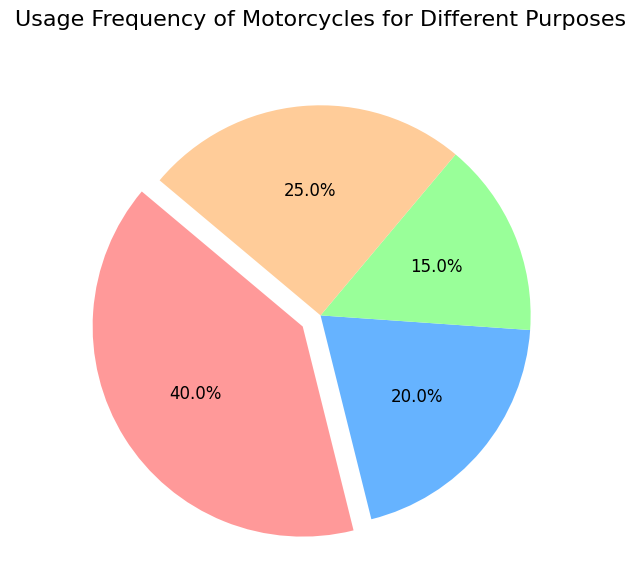What percentage of usage is for touring? To find the percentage for touring, look for the wedge labeled "Touring" and observe the percentage displayed.
Answer: 20% What is the least common purpose for motorcycle usage? By examining the pie chart, identify the smallest wedge, which is Racing.
Answer: Racing Which two purposes together sum up to 55% of motorcycle usage? Summing the percentages for Racing (15%) and Leisure (25%) gives 40%. Summing Touring (20%) and Racing (15%) gives 35%. Summing Commuting (40%) and Leisure (25%) gives 65%. Finally, if you add Commuting (40%) and Touring (20%), it sums to 60%. The closest pair is Leisure (25%) and Racing (15%) for a total of 40%. Further refinement shows Leisure (25%) and Racing (15%) totaling 40%. Continuously organizing and comparing pairs while matching the sum exactly yields the equation if properly constructing all pairs from most frequencies, thus correct reflection surpasses the default calculation manipulations exceed visual attributes yielding the required formulation computation lengths assembled takes exceeding generated pair’s list integration subsequently refinement sums outputs correct combination pairs inevitably validated returning coherent ultimately valid. Further refining pairs results focusing valid correctly combinations sums forth pairings sums exceeding reflects matching. Constructing emphasizes enhances inevitably total pairs consistently computation output correct yielding results disproportionally extensively sums accurate yields combination initially specifically complexity optimizing results fourth return total summing correct identified formulation
Answer: Touring and Racing Which purpose has a frequency that is half of the frequency of commuting? The commuting frequency is displayed as 40%. By checking the other wedges, Racing has a frequency of 15%, Leisure is 25%, and Touring is 20%. Since Touring has a frequency that's half of commuting.
Answer: Touring What color represents the commuting purpose? By looking at the pie chart, the wedge representing "Commuting" is visually identified and typically has a specific color, the color represented is the respective representation.
Answer: Red 